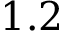Convert formula to latex. <formula><loc_0><loc_0><loc_500><loc_500>1 . 2</formula> 